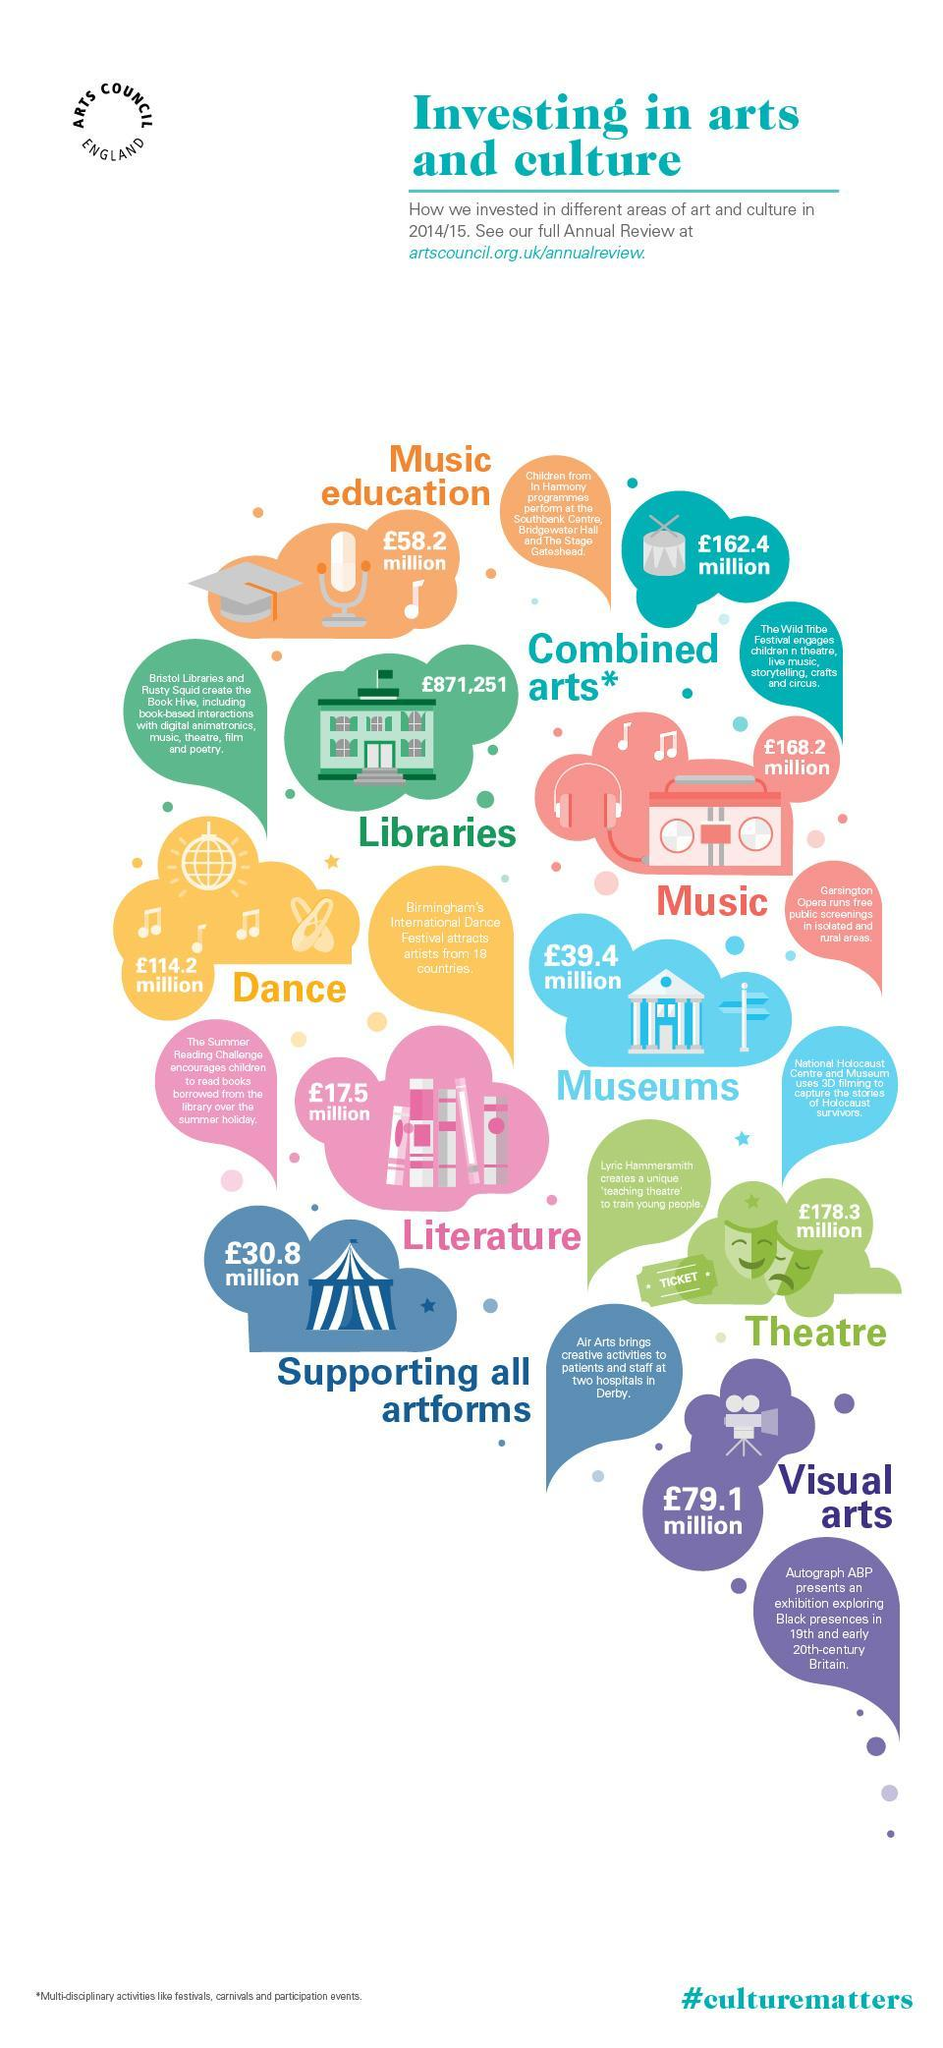What is the amount invested in theatre teaching by U.K. in 2014/15?
Answer the question with a short phrase. £178.3 milllion What is the amount invested in Literature by U.K. in 2014/15? £17.5 milllion In which area of art & culture, the UK government has invested least amount of money in 2014/15? Libraries What is the amount invested in music education by U.K. in 2014/15? £58.2 milllion In which area of art & culture, the UK government has invested most of their money in 2014/15? Theatre 